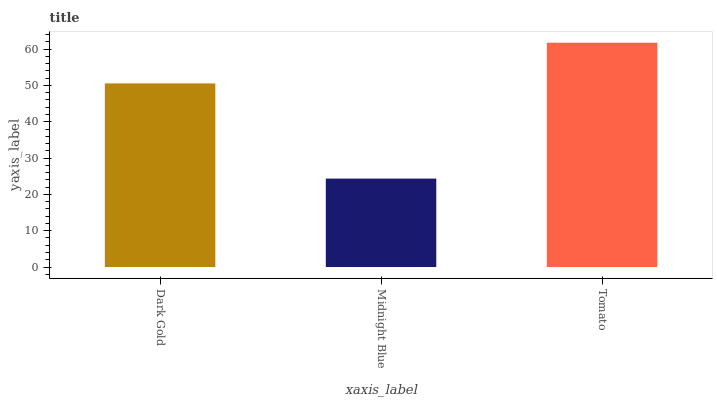Is Tomato the minimum?
Answer yes or no. No. Is Midnight Blue the maximum?
Answer yes or no. No. Is Tomato greater than Midnight Blue?
Answer yes or no. Yes. Is Midnight Blue less than Tomato?
Answer yes or no. Yes. Is Midnight Blue greater than Tomato?
Answer yes or no. No. Is Tomato less than Midnight Blue?
Answer yes or no. No. Is Dark Gold the high median?
Answer yes or no. Yes. Is Dark Gold the low median?
Answer yes or no. Yes. Is Tomato the high median?
Answer yes or no. No. Is Tomato the low median?
Answer yes or no. No. 